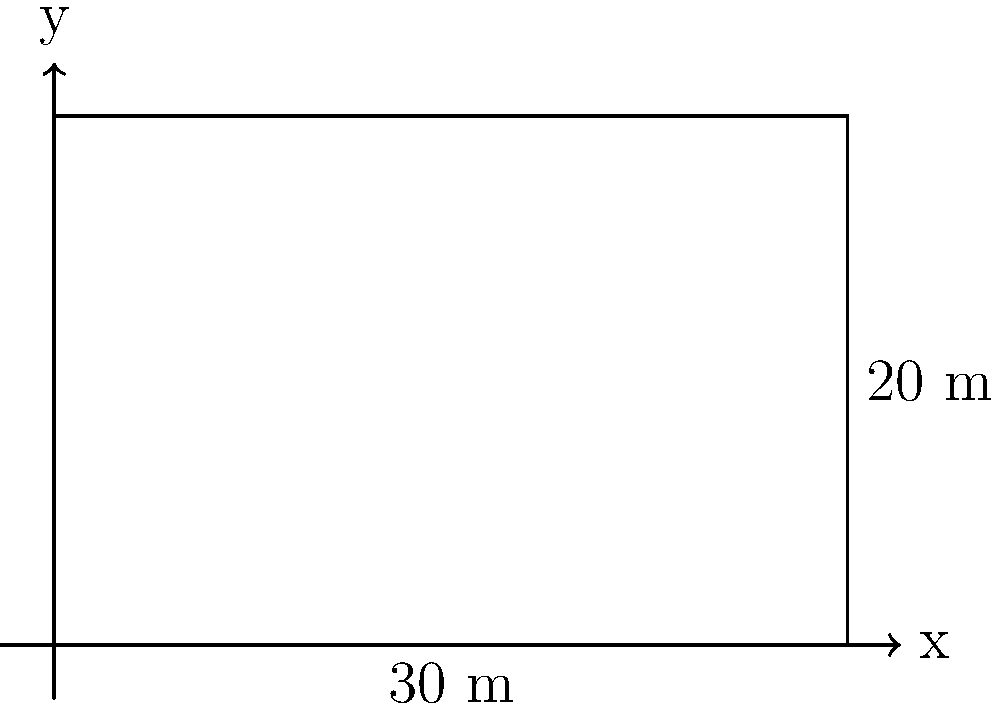As a community organizer planning a local event featuring a trauma surgeon, you're designing a rectangular community garden to commemorate their contributions. The garden measures 30 meters in length and 20 meters in width. What is the perimeter of this garden? To find the perimeter of a rectangular garden, we need to add up the lengths of all four sides. Let's approach this step-by-step:

1. Identify the given dimensions:
   - Length (l) = 30 meters
   - Width (w) = 20 meters

2. Recall the formula for the perimeter of a rectangle:
   $$ P = 2l + 2w $$
   where P is the perimeter, l is the length, and w is the width.

3. Substitute the given values into the formula:
   $$ P = 2(30) + 2(20) $$

4. Simplify:
   $$ P = 60 + 40 $$

5. Calculate the final result:
   $$ P = 100 $$

Therefore, the perimeter of the rectangular community garden is 100 meters.
Answer: 100 meters 